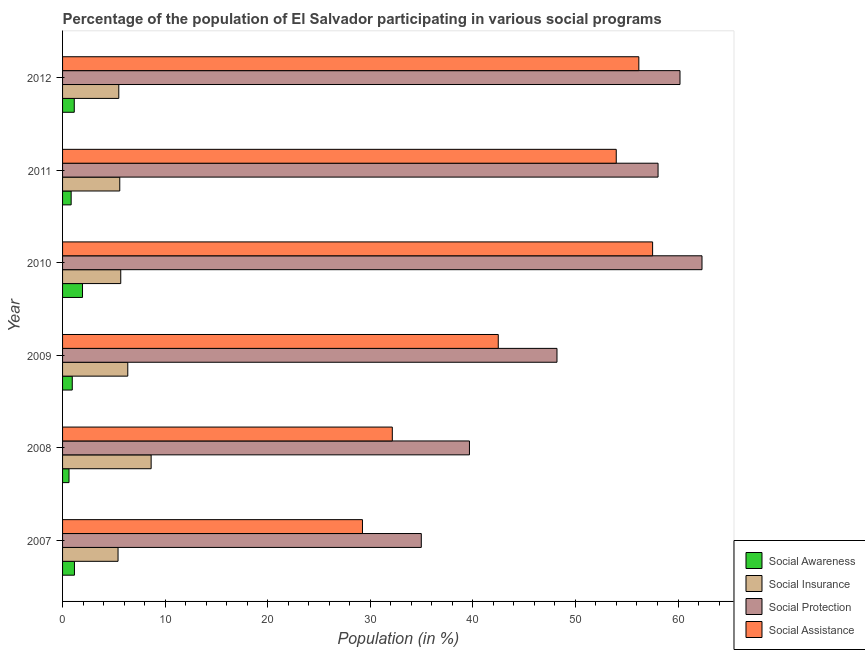How many different coloured bars are there?
Your response must be concise. 4. Are the number of bars per tick equal to the number of legend labels?
Your response must be concise. Yes. What is the label of the 1st group of bars from the top?
Provide a short and direct response. 2012. What is the participation of population in social awareness programs in 2009?
Your answer should be very brief. 0.95. Across all years, what is the maximum participation of population in social insurance programs?
Offer a very short reply. 8.63. Across all years, what is the minimum participation of population in social awareness programs?
Offer a terse response. 0.63. In which year was the participation of population in social protection programs minimum?
Ensure brevity in your answer.  2007. What is the total participation of population in social insurance programs in the graph?
Your answer should be compact. 37.13. What is the difference between the participation of population in social awareness programs in 2010 and that in 2012?
Your answer should be compact. 0.81. What is the difference between the participation of population in social assistance programs in 2009 and the participation of population in social protection programs in 2010?
Give a very brief answer. -19.86. What is the average participation of population in social assistance programs per year?
Ensure brevity in your answer.  45.26. In the year 2012, what is the difference between the participation of population in social insurance programs and participation of population in social protection programs?
Your answer should be very brief. -54.71. What is the ratio of the participation of population in social assistance programs in 2009 to that in 2010?
Provide a short and direct response. 0.74. Is the participation of population in social insurance programs in 2009 less than that in 2010?
Keep it short and to the point. No. What is the difference between the highest and the second highest participation of population in social awareness programs?
Offer a very short reply. 0.79. What is the difference between the highest and the lowest participation of population in social assistance programs?
Keep it short and to the point. 28.29. In how many years, is the participation of population in social awareness programs greater than the average participation of population in social awareness programs taken over all years?
Offer a very short reply. 3. Is it the case that in every year, the sum of the participation of population in social protection programs and participation of population in social awareness programs is greater than the sum of participation of population in social assistance programs and participation of population in social insurance programs?
Provide a succinct answer. Yes. What does the 4th bar from the top in 2011 represents?
Keep it short and to the point. Social Awareness. What does the 3rd bar from the bottom in 2010 represents?
Ensure brevity in your answer.  Social Protection. Are all the bars in the graph horizontal?
Provide a short and direct response. Yes. How many years are there in the graph?
Ensure brevity in your answer.  6. Are the values on the major ticks of X-axis written in scientific E-notation?
Ensure brevity in your answer.  No. How many legend labels are there?
Your response must be concise. 4. What is the title of the graph?
Ensure brevity in your answer.  Percentage of the population of El Salvador participating in various social programs . Does "Taxes on income" appear as one of the legend labels in the graph?
Give a very brief answer. No. What is the Population (in %) of Social Awareness in 2007?
Make the answer very short. 1.16. What is the Population (in %) of Social Insurance in 2007?
Provide a succinct answer. 5.41. What is the Population (in %) in Social Protection in 2007?
Make the answer very short. 34.97. What is the Population (in %) of Social Assistance in 2007?
Offer a terse response. 29.24. What is the Population (in %) of Social Awareness in 2008?
Give a very brief answer. 0.63. What is the Population (in %) of Social Insurance in 2008?
Your answer should be compact. 8.63. What is the Population (in %) of Social Protection in 2008?
Provide a short and direct response. 39.67. What is the Population (in %) of Social Assistance in 2008?
Your answer should be compact. 32.15. What is the Population (in %) of Social Awareness in 2009?
Ensure brevity in your answer.  0.95. What is the Population (in %) in Social Insurance in 2009?
Ensure brevity in your answer.  6.36. What is the Population (in %) in Social Protection in 2009?
Your response must be concise. 48.2. What is the Population (in %) in Social Assistance in 2009?
Provide a short and direct response. 42.48. What is the Population (in %) in Social Awareness in 2010?
Offer a terse response. 1.95. What is the Population (in %) in Social Insurance in 2010?
Offer a very short reply. 5.67. What is the Population (in %) in Social Protection in 2010?
Provide a short and direct response. 62.34. What is the Population (in %) of Social Assistance in 2010?
Your answer should be compact. 57.53. What is the Population (in %) of Social Awareness in 2011?
Keep it short and to the point. 0.84. What is the Population (in %) of Social Insurance in 2011?
Your answer should be very brief. 5.58. What is the Population (in %) in Social Protection in 2011?
Provide a short and direct response. 58.06. What is the Population (in %) of Social Assistance in 2011?
Ensure brevity in your answer.  53.98. What is the Population (in %) of Social Awareness in 2012?
Offer a very short reply. 1.14. What is the Population (in %) of Social Insurance in 2012?
Provide a succinct answer. 5.48. What is the Population (in %) in Social Protection in 2012?
Offer a very short reply. 60.19. What is the Population (in %) in Social Assistance in 2012?
Offer a terse response. 56.18. Across all years, what is the maximum Population (in %) in Social Awareness?
Give a very brief answer. 1.95. Across all years, what is the maximum Population (in %) of Social Insurance?
Offer a very short reply. 8.63. Across all years, what is the maximum Population (in %) in Social Protection?
Your response must be concise. 62.34. Across all years, what is the maximum Population (in %) of Social Assistance?
Your answer should be compact. 57.53. Across all years, what is the minimum Population (in %) in Social Awareness?
Make the answer very short. 0.63. Across all years, what is the minimum Population (in %) in Social Insurance?
Offer a terse response. 5.41. Across all years, what is the minimum Population (in %) in Social Protection?
Your answer should be very brief. 34.97. Across all years, what is the minimum Population (in %) of Social Assistance?
Make the answer very short. 29.24. What is the total Population (in %) of Social Awareness in the graph?
Make the answer very short. 6.66. What is the total Population (in %) of Social Insurance in the graph?
Your response must be concise. 37.13. What is the total Population (in %) of Social Protection in the graph?
Ensure brevity in your answer.  303.43. What is the total Population (in %) of Social Assistance in the graph?
Provide a succinct answer. 271.55. What is the difference between the Population (in %) in Social Awareness in 2007 and that in 2008?
Your answer should be compact. 0.53. What is the difference between the Population (in %) of Social Insurance in 2007 and that in 2008?
Provide a succinct answer. -3.23. What is the difference between the Population (in %) in Social Protection in 2007 and that in 2008?
Keep it short and to the point. -4.7. What is the difference between the Population (in %) of Social Assistance in 2007 and that in 2008?
Keep it short and to the point. -2.91. What is the difference between the Population (in %) of Social Awareness in 2007 and that in 2009?
Provide a succinct answer. 0.21. What is the difference between the Population (in %) of Social Insurance in 2007 and that in 2009?
Your answer should be very brief. -0.95. What is the difference between the Population (in %) of Social Protection in 2007 and that in 2009?
Ensure brevity in your answer.  -13.23. What is the difference between the Population (in %) in Social Assistance in 2007 and that in 2009?
Give a very brief answer. -13.24. What is the difference between the Population (in %) in Social Awareness in 2007 and that in 2010?
Provide a succinct answer. -0.79. What is the difference between the Population (in %) in Social Insurance in 2007 and that in 2010?
Your answer should be compact. -0.26. What is the difference between the Population (in %) of Social Protection in 2007 and that in 2010?
Offer a terse response. -27.37. What is the difference between the Population (in %) of Social Assistance in 2007 and that in 2010?
Your answer should be very brief. -28.29. What is the difference between the Population (in %) of Social Awareness in 2007 and that in 2011?
Offer a terse response. 0.32. What is the difference between the Population (in %) of Social Insurance in 2007 and that in 2011?
Make the answer very short. -0.17. What is the difference between the Population (in %) of Social Protection in 2007 and that in 2011?
Keep it short and to the point. -23.08. What is the difference between the Population (in %) of Social Assistance in 2007 and that in 2011?
Offer a very short reply. -24.74. What is the difference between the Population (in %) of Social Awareness in 2007 and that in 2012?
Your answer should be compact. 0.02. What is the difference between the Population (in %) of Social Insurance in 2007 and that in 2012?
Your answer should be very brief. -0.07. What is the difference between the Population (in %) of Social Protection in 2007 and that in 2012?
Your answer should be compact. -25.22. What is the difference between the Population (in %) of Social Assistance in 2007 and that in 2012?
Provide a succinct answer. -26.94. What is the difference between the Population (in %) in Social Awareness in 2008 and that in 2009?
Offer a terse response. -0.32. What is the difference between the Population (in %) of Social Insurance in 2008 and that in 2009?
Offer a very short reply. 2.28. What is the difference between the Population (in %) of Social Protection in 2008 and that in 2009?
Provide a succinct answer. -8.53. What is the difference between the Population (in %) in Social Assistance in 2008 and that in 2009?
Offer a terse response. -10.33. What is the difference between the Population (in %) in Social Awareness in 2008 and that in 2010?
Your answer should be very brief. -1.32. What is the difference between the Population (in %) of Social Insurance in 2008 and that in 2010?
Your response must be concise. 2.96. What is the difference between the Population (in %) in Social Protection in 2008 and that in 2010?
Your answer should be compact. -22.67. What is the difference between the Population (in %) in Social Assistance in 2008 and that in 2010?
Your answer should be very brief. -25.38. What is the difference between the Population (in %) in Social Awareness in 2008 and that in 2011?
Your answer should be compact. -0.21. What is the difference between the Population (in %) in Social Insurance in 2008 and that in 2011?
Keep it short and to the point. 3.06. What is the difference between the Population (in %) in Social Protection in 2008 and that in 2011?
Offer a very short reply. -18.39. What is the difference between the Population (in %) of Social Assistance in 2008 and that in 2011?
Offer a terse response. -21.83. What is the difference between the Population (in %) in Social Awareness in 2008 and that in 2012?
Ensure brevity in your answer.  -0.51. What is the difference between the Population (in %) of Social Insurance in 2008 and that in 2012?
Ensure brevity in your answer.  3.15. What is the difference between the Population (in %) of Social Protection in 2008 and that in 2012?
Give a very brief answer. -20.53. What is the difference between the Population (in %) of Social Assistance in 2008 and that in 2012?
Offer a terse response. -24.03. What is the difference between the Population (in %) in Social Awareness in 2009 and that in 2010?
Keep it short and to the point. -1. What is the difference between the Population (in %) of Social Insurance in 2009 and that in 2010?
Your answer should be compact. 0.68. What is the difference between the Population (in %) of Social Protection in 2009 and that in 2010?
Your answer should be compact. -14.14. What is the difference between the Population (in %) in Social Assistance in 2009 and that in 2010?
Give a very brief answer. -15.05. What is the difference between the Population (in %) in Social Awareness in 2009 and that in 2011?
Keep it short and to the point. 0.11. What is the difference between the Population (in %) in Social Insurance in 2009 and that in 2011?
Offer a very short reply. 0.78. What is the difference between the Population (in %) of Social Protection in 2009 and that in 2011?
Ensure brevity in your answer.  -9.86. What is the difference between the Population (in %) of Social Assistance in 2009 and that in 2011?
Give a very brief answer. -11.5. What is the difference between the Population (in %) in Social Awareness in 2009 and that in 2012?
Make the answer very short. -0.2. What is the difference between the Population (in %) of Social Protection in 2009 and that in 2012?
Keep it short and to the point. -11.99. What is the difference between the Population (in %) in Social Assistance in 2009 and that in 2012?
Keep it short and to the point. -13.7. What is the difference between the Population (in %) of Social Awareness in 2010 and that in 2011?
Keep it short and to the point. 1.11. What is the difference between the Population (in %) of Social Insurance in 2010 and that in 2011?
Provide a succinct answer. 0.1. What is the difference between the Population (in %) of Social Protection in 2010 and that in 2011?
Your response must be concise. 4.28. What is the difference between the Population (in %) in Social Assistance in 2010 and that in 2011?
Ensure brevity in your answer.  3.55. What is the difference between the Population (in %) of Social Awareness in 2010 and that in 2012?
Offer a very short reply. 0.8. What is the difference between the Population (in %) of Social Insurance in 2010 and that in 2012?
Offer a very short reply. 0.19. What is the difference between the Population (in %) of Social Protection in 2010 and that in 2012?
Provide a short and direct response. 2.15. What is the difference between the Population (in %) in Social Assistance in 2010 and that in 2012?
Give a very brief answer. 1.34. What is the difference between the Population (in %) in Social Awareness in 2011 and that in 2012?
Ensure brevity in your answer.  -0.3. What is the difference between the Population (in %) in Social Insurance in 2011 and that in 2012?
Provide a short and direct response. 0.09. What is the difference between the Population (in %) in Social Protection in 2011 and that in 2012?
Ensure brevity in your answer.  -2.14. What is the difference between the Population (in %) of Social Assistance in 2011 and that in 2012?
Your answer should be very brief. -2.2. What is the difference between the Population (in %) in Social Awareness in 2007 and the Population (in %) in Social Insurance in 2008?
Offer a terse response. -7.48. What is the difference between the Population (in %) in Social Awareness in 2007 and the Population (in %) in Social Protection in 2008?
Your answer should be compact. -38.51. What is the difference between the Population (in %) of Social Awareness in 2007 and the Population (in %) of Social Assistance in 2008?
Your response must be concise. -30.99. What is the difference between the Population (in %) in Social Insurance in 2007 and the Population (in %) in Social Protection in 2008?
Offer a very short reply. -34.26. What is the difference between the Population (in %) of Social Insurance in 2007 and the Population (in %) of Social Assistance in 2008?
Provide a succinct answer. -26.74. What is the difference between the Population (in %) of Social Protection in 2007 and the Population (in %) of Social Assistance in 2008?
Your answer should be very brief. 2.83. What is the difference between the Population (in %) of Social Awareness in 2007 and the Population (in %) of Social Insurance in 2009?
Provide a succinct answer. -5.2. What is the difference between the Population (in %) of Social Awareness in 2007 and the Population (in %) of Social Protection in 2009?
Your answer should be very brief. -47.04. What is the difference between the Population (in %) in Social Awareness in 2007 and the Population (in %) in Social Assistance in 2009?
Keep it short and to the point. -41.32. What is the difference between the Population (in %) of Social Insurance in 2007 and the Population (in %) of Social Protection in 2009?
Offer a very short reply. -42.79. What is the difference between the Population (in %) of Social Insurance in 2007 and the Population (in %) of Social Assistance in 2009?
Your answer should be compact. -37.07. What is the difference between the Population (in %) of Social Protection in 2007 and the Population (in %) of Social Assistance in 2009?
Provide a short and direct response. -7.5. What is the difference between the Population (in %) in Social Awareness in 2007 and the Population (in %) in Social Insurance in 2010?
Ensure brevity in your answer.  -4.51. What is the difference between the Population (in %) of Social Awareness in 2007 and the Population (in %) of Social Protection in 2010?
Offer a terse response. -61.18. What is the difference between the Population (in %) of Social Awareness in 2007 and the Population (in %) of Social Assistance in 2010?
Your answer should be very brief. -56.37. What is the difference between the Population (in %) in Social Insurance in 2007 and the Population (in %) in Social Protection in 2010?
Offer a terse response. -56.93. What is the difference between the Population (in %) of Social Insurance in 2007 and the Population (in %) of Social Assistance in 2010?
Provide a short and direct response. -52.12. What is the difference between the Population (in %) in Social Protection in 2007 and the Population (in %) in Social Assistance in 2010?
Give a very brief answer. -22.55. What is the difference between the Population (in %) in Social Awareness in 2007 and the Population (in %) in Social Insurance in 2011?
Make the answer very short. -4.42. What is the difference between the Population (in %) in Social Awareness in 2007 and the Population (in %) in Social Protection in 2011?
Make the answer very short. -56.9. What is the difference between the Population (in %) of Social Awareness in 2007 and the Population (in %) of Social Assistance in 2011?
Your response must be concise. -52.82. What is the difference between the Population (in %) in Social Insurance in 2007 and the Population (in %) in Social Protection in 2011?
Ensure brevity in your answer.  -52.65. What is the difference between the Population (in %) of Social Insurance in 2007 and the Population (in %) of Social Assistance in 2011?
Provide a short and direct response. -48.57. What is the difference between the Population (in %) of Social Protection in 2007 and the Population (in %) of Social Assistance in 2011?
Provide a succinct answer. -19.01. What is the difference between the Population (in %) in Social Awareness in 2007 and the Population (in %) in Social Insurance in 2012?
Provide a short and direct response. -4.32. What is the difference between the Population (in %) of Social Awareness in 2007 and the Population (in %) of Social Protection in 2012?
Ensure brevity in your answer.  -59.03. What is the difference between the Population (in %) of Social Awareness in 2007 and the Population (in %) of Social Assistance in 2012?
Ensure brevity in your answer.  -55.02. What is the difference between the Population (in %) of Social Insurance in 2007 and the Population (in %) of Social Protection in 2012?
Ensure brevity in your answer.  -54.79. What is the difference between the Population (in %) of Social Insurance in 2007 and the Population (in %) of Social Assistance in 2012?
Give a very brief answer. -50.77. What is the difference between the Population (in %) of Social Protection in 2007 and the Population (in %) of Social Assistance in 2012?
Offer a very short reply. -21.21. What is the difference between the Population (in %) in Social Awareness in 2008 and the Population (in %) in Social Insurance in 2009?
Your answer should be very brief. -5.73. What is the difference between the Population (in %) of Social Awareness in 2008 and the Population (in %) of Social Protection in 2009?
Offer a terse response. -47.57. What is the difference between the Population (in %) of Social Awareness in 2008 and the Population (in %) of Social Assistance in 2009?
Offer a very short reply. -41.85. What is the difference between the Population (in %) in Social Insurance in 2008 and the Population (in %) in Social Protection in 2009?
Ensure brevity in your answer.  -39.57. What is the difference between the Population (in %) in Social Insurance in 2008 and the Population (in %) in Social Assistance in 2009?
Your answer should be compact. -33.84. What is the difference between the Population (in %) in Social Protection in 2008 and the Population (in %) in Social Assistance in 2009?
Make the answer very short. -2.81. What is the difference between the Population (in %) of Social Awareness in 2008 and the Population (in %) of Social Insurance in 2010?
Your answer should be very brief. -5.04. What is the difference between the Population (in %) of Social Awareness in 2008 and the Population (in %) of Social Protection in 2010?
Give a very brief answer. -61.71. What is the difference between the Population (in %) of Social Awareness in 2008 and the Population (in %) of Social Assistance in 2010?
Provide a short and direct response. -56.9. What is the difference between the Population (in %) of Social Insurance in 2008 and the Population (in %) of Social Protection in 2010?
Ensure brevity in your answer.  -53.71. What is the difference between the Population (in %) in Social Insurance in 2008 and the Population (in %) in Social Assistance in 2010?
Make the answer very short. -48.89. What is the difference between the Population (in %) of Social Protection in 2008 and the Population (in %) of Social Assistance in 2010?
Your answer should be compact. -17.86. What is the difference between the Population (in %) of Social Awareness in 2008 and the Population (in %) of Social Insurance in 2011?
Give a very brief answer. -4.95. What is the difference between the Population (in %) in Social Awareness in 2008 and the Population (in %) in Social Protection in 2011?
Provide a succinct answer. -57.43. What is the difference between the Population (in %) in Social Awareness in 2008 and the Population (in %) in Social Assistance in 2011?
Ensure brevity in your answer.  -53.35. What is the difference between the Population (in %) in Social Insurance in 2008 and the Population (in %) in Social Protection in 2011?
Offer a very short reply. -49.42. What is the difference between the Population (in %) of Social Insurance in 2008 and the Population (in %) of Social Assistance in 2011?
Make the answer very short. -45.34. What is the difference between the Population (in %) of Social Protection in 2008 and the Population (in %) of Social Assistance in 2011?
Make the answer very short. -14.31. What is the difference between the Population (in %) of Social Awareness in 2008 and the Population (in %) of Social Insurance in 2012?
Your answer should be very brief. -4.85. What is the difference between the Population (in %) of Social Awareness in 2008 and the Population (in %) of Social Protection in 2012?
Ensure brevity in your answer.  -59.57. What is the difference between the Population (in %) in Social Awareness in 2008 and the Population (in %) in Social Assistance in 2012?
Your response must be concise. -55.55. What is the difference between the Population (in %) of Social Insurance in 2008 and the Population (in %) of Social Protection in 2012?
Your answer should be compact. -51.56. What is the difference between the Population (in %) in Social Insurance in 2008 and the Population (in %) in Social Assistance in 2012?
Provide a short and direct response. -47.55. What is the difference between the Population (in %) in Social Protection in 2008 and the Population (in %) in Social Assistance in 2012?
Offer a terse response. -16.51. What is the difference between the Population (in %) in Social Awareness in 2009 and the Population (in %) in Social Insurance in 2010?
Ensure brevity in your answer.  -4.73. What is the difference between the Population (in %) in Social Awareness in 2009 and the Population (in %) in Social Protection in 2010?
Ensure brevity in your answer.  -61.4. What is the difference between the Population (in %) in Social Awareness in 2009 and the Population (in %) in Social Assistance in 2010?
Your response must be concise. -56.58. What is the difference between the Population (in %) in Social Insurance in 2009 and the Population (in %) in Social Protection in 2010?
Provide a short and direct response. -55.98. What is the difference between the Population (in %) of Social Insurance in 2009 and the Population (in %) of Social Assistance in 2010?
Provide a succinct answer. -51.17. What is the difference between the Population (in %) in Social Protection in 2009 and the Population (in %) in Social Assistance in 2010?
Keep it short and to the point. -9.32. What is the difference between the Population (in %) of Social Awareness in 2009 and the Population (in %) of Social Insurance in 2011?
Keep it short and to the point. -4.63. What is the difference between the Population (in %) in Social Awareness in 2009 and the Population (in %) in Social Protection in 2011?
Provide a short and direct response. -57.11. What is the difference between the Population (in %) in Social Awareness in 2009 and the Population (in %) in Social Assistance in 2011?
Give a very brief answer. -53.03. What is the difference between the Population (in %) in Social Insurance in 2009 and the Population (in %) in Social Protection in 2011?
Your answer should be very brief. -51.7. What is the difference between the Population (in %) of Social Insurance in 2009 and the Population (in %) of Social Assistance in 2011?
Offer a very short reply. -47.62. What is the difference between the Population (in %) of Social Protection in 2009 and the Population (in %) of Social Assistance in 2011?
Offer a very short reply. -5.78. What is the difference between the Population (in %) in Social Awareness in 2009 and the Population (in %) in Social Insurance in 2012?
Give a very brief answer. -4.54. What is the difference between the Population (in %) in Social Awareness in 2009 and the Population (in %) in Social Protection in 2012?
Make the answer very short. -59.25. What is the difference between the Population (in %) of Social Awareness in 2009 and the Population (in %) of Social Assistance in 2012?
Offer a very short reply. -55.24. What is the difference between the Population (in %) of Social Insurance in 2009 and the Population (in %) of Social Protection in 2012?
Offer a very short reply. -53.84. What is the difference between the Population (in %) in Social Insurance in 2009 and the Population (in %) in Social Assistance in 2012?
Your answer should be very brief. -49.82. What is the difference between the Population (in %) in Social Protection in 2009 and the Population (in %) in Social Assistance in 2012?
Offer a very short reply. -7.98. What is the difference between the Population (in %) in Social Awareness in 2010 and the Population (in %) in Social Insurance in 2011?
Your answer should be very brief. -3.63. What is the difference between the Population (in %) in Social Awareness in 2010 and the Population (in %) in Social Protection in 2011?
Your response must be concise. -56.11. What is the difference between the Population (in %) in Social Awareness in 2010 and the Population (in %) in Social Assistance in 2011?
Your answer should be compact. -52.03. What is the difference between the Population (in %) in Social Insurance in 2010 and the Population (in %) in Social Protection in 2011?
Your response must be concise. -52.38. What is the difference between the Population (in %) of Social Insurance in 2010 and the Population (in %) of Social Assistance in 2011?
Offer a terse response. -48.31. What is the difference between the Population (in %) in Social Protection in 2010 and the Population (in %) in Social Assistance in 2011?
Your answer should be very brief. 8.36. What is the difference between the Population (in %) of Social Awareness in 2010 and the Population (in %) of Social Insurance in 2012?
Ensure brevity in your answer.  -3.54. What is the difference between the Population (in %) in Social Awareness in 2010 and the Population (in %) in Social Protection in 2012?
Provide a short and direct response. -58.25. What is the difference between the Population (in %) of Social Awareness in 2010 and the Population (in %) of Social Assistance in 2012?
Offer a terse response. -54.24. What is the difference between the Population (in %) of Social Insurance in 2010 and the Population (in %) of Social Protection in 2012?
Your answer should be very brief. -54.52. What is the difference between the Population (in %) in Social Insurance in 2010 and the Population (in %) in Social Assistance in 2012?
Keep it short and to the point. -50.51. What is the difference between the Population (in %) in Social Protection in 2010 and the Population (in %) in Social Assistance in 2012?
Provide a short and direct response. 6.16. What is the difference between the Population (in %) in Social Awareness in 2011 and the Population (in %) in Social Insurance in 2012?
Keep it short and to the point. -4.65. What is the difference between the Population (in %) of Social Awareness in 2011 and the Population (in %) of Social Protection in 2012?
Your answer should be very brief. -59.36. What is the difference between the Population (in %) of Social Awareness in 2011 and the Population (in %) of Social Assistance in 2012?
Offer a very short reply. -55.34. What is the difference between the Population (in %) in Social Insurance in 2011 and the Population (in %) in Social Protection in 2012?
Make the answer very short. -54.62. What is the difference between the Population (in %) in Social Insurance in 2011 and the Population (in %) in Social Assistance in 2012?
Offer a terse response. -50.6. What is the difference between the Population (in %) in Social Protection in 2011 and the Population (in %) in Social Assistance in 2012?
Give a very brief answer. 1.88. What is the average Population (in %) in Social Awareness per year?
Give a very brief answer. 1.11. What is the average Population (in %) of Social Insurance per year?
Your answer should be compact. 6.19. What is the average Population (in %) in Social Protection per year?
Offer a very short reply. 50.57. What is the average Population (in %) in Social Assistance per year?
Offer a very short reply. 45.26. In the year 2007, what is the difference between the Population (in %) of Social Awareness and Population (in %) of Social Insurance?
Your answer should be very brief. -4.25. In the year 2007, what is the difference between the Population (in %) in Social Awareness and Population (in %) in Social Protection?
Your answer should be very brief. -33.81. In the year 2007, what is the difference between the Population (in %) in Social Awareness and Population (in %) in Social Assistance?
Offer a very short reply. -28.08. In the year 2007, what is the difference between the Population (in %) in Social Insurance and Population (in %) in Social Protection?
Give a very brief answer. -29.56. In the year 2007, what is the difference between the Population (in %) of Social Insurance and Population (in %) of Social Assistance?
Ensure brevity in your answer.  -23.83. In the year 2007, what is the difference between the Population (in %) of Social Protection and Population (in %) of Social Assistance?
Make the answer very short. 5.74. In the year 2008, what is the difference between the Population (in %) in Social Awareness and Population (in %) in Social Insurance?
Give a very brief answer. -8.01. In the year 2008, what is the difference between the Population (in %) in Social Awareness and Population (in %) in Social Protection?
Provide a short and direct response. -39.04. In the year 2008, what is the difference between the Population (in %) in Social Awareness and Population (in %) in Social Assistance?
Offer a very short reply. -31.52. In the year 2008, what is the difference between the Population (in %) of Social Insurance and Population (in %) of Social Protection?
Provide a succinct answer. -31.03. In the year 2008, what is the difference between the Population (in %) of Social Insurance and Population (in %) of Social Assistance?
Make the answer very short. -23.51. In the year 2008, what is the difference between the Population (in %) of Social Protection and Population (in %) of Social Assistance?
Ensure brevity in your answer.  7.52. In the year 2009, what is the difference between the Population (in %) in Social Awareness and Population (in %) in Social Insurance?
Give a very brief answer. -5.41. In the year 2009, what is the difference between the Population (in %) of Social Awareness and Population (in %) of Social Protection?
Your answer should be compact. -47.26. In the year 2009, what is the difference between the Population (in %) of Social Awareness and Population (in %) of Social Assistance?
Your answer should be very brief. -41.53. In the year 2009, what is the difference between the Population (in %) in Social Insurance and Population (in %) in Social Protection?
Keep it short and to the point. -41.84. In the year 2009, what is the difference between the Population (in %) of Social Insurance and Population (in %) of Social Assistance?
Give a very brief answer. -36.12. In the year 2009, what is the difference between the Population (in %) of Social Protection and Population (in %) of Social Assistance?
Your response must be concise. 5.72. In the year 2010, what is the difference between the Population (in %) in Social Awareness and Population (in %) in Social Insurance?
Ensure brevity in your answer.  -3.73. In the year 2010, what is the difference between the Population (in %) of Social Awareness and Population (in %) of Social Protection?
Your answer should be very brief. -60.39. In the year 2010, what is the difference between the Population (in %) of Social Awareness and Population (in %) of Social Assistance?
Make the answer very short. -55.58. In the year 2010, what is the difference between the Population (in %) of Social Insurance and Population (in %) of Social Protection?
Make the answer very short. -56.67. In the year 2010, what is the difference between the Population (in %) of Social Insurance and Population (in %) of Social Assistance?
Offer a very short reply. -51.85. In the year 2010, what is the difference between the Population (in %) of Social Protection and Population (in %) of Social Assistance?
Provide a short and direct response. 4.82. In the year 2011, what is the difference between the Population (in %) in Social Awareness and Population (in %) in Social Insurance?
Keep it short and to the point. -4.74. In the year 2011, what is the difference between the Population (in %) in Social Awareness and Population (in %) in Social Protection?
Offer a very short reply. -57.22. In the year 2011, what is the difference between the Population (in %) in Social Awareness and Population (in %) in Social Assistance?
Your response must be concise. -53.14. In the year 2011, what is the difference between the Population (in %) in Social Insurance and Population (in %) in Social Protection?
Your answer should be compact. -52.48. In the year 2011, what is the difference between the Population (in %) of Social Insurance and Population (in %) of Social Assistance?
Provide a short and direct response. -48.4. In the year 2011, what is the difference between the Population (in %) in Social Protection and Population (in %) in Social Assistance?
Make the answer very short. 4.08. In the year 2012, what is the difference between the Population (in %) in Social Awareness and Population (in %) in Social Insurance?
Your answer should be very brief. -4.34. In the year 2012, what is the difference between the Population (in %) in Social Awareness and Population (in %) in Social Protection?
Make the answer very short. -59.05. In the year 2012, what is the difference between the Population (in %) of Social Awareness and Population (in %) of Social Assistance?
Give a very brief answer. -55.04. In the year 2012, what is the difference between the Population (in %) of Social Insurance and Population (in %) of Social Protection?
Make the answer very short. -54.71. In the year 2012, what is the difference between the Population (in %) of Social Insurance and Population (in %) of Social Assistance?
Make the answer very short. -50.7. In the year 2012, what is the difference between the Population (in %) of Social Protection and Population (in %) of Social Assistance?
Provide a short and direct response. 4.01. What is the ratio of the Population (in %) in Social Awareness in 2007 to that in 2008?
Ensure brevity in your answer.  1.84. What is the ratio of the Population (in %) in Social Insurance in 2007 to that in 2008?
Your answer should be compact. 0.63. What is the ratio of the Population (in %) of Social Protection in 2007 to that in 2008?
Your answer should be compact. 0.88. What is the ratio of the Population (in %) in Social Assistance in 2007 to that in 2008?
Provide a short and direct response. 0.91. What is the ratio of the Population (in %) in Social Awareness in 2007 to that in 2009?
Your answer should be compact. 1.23. What is the ratio of the Population (in %) in Social Insurance in 2007 to that in 2009?
Offer a terse response. 0.85. What is the ratio of the Population (in %) of Social Protection in 2007 to that in 2009?
Make the answer very short. 0.73. What is the ratio of the Population (in %) in Social Assistance in 2007 to that in 2009?
Provide a succinct answer. 0.69. What is the ratio of the Population (in %) in Social Awareness in 2007 to that in 2010?
Give a very brief answer. 0.6. What is the ratio of the Population (in %) of Social Insurance in 2007 to that in 2010?
Keep it short and to the point. 0.95. What is the ratio of the Population (in %) in Social Protection in 2007 to that in 2010?
Give a very brief answer. 0.56. What is the ratio of the Population (in %) in Social Assistance in 2007 to that in 2010?
Provide a succinct answer. 0.51. What is the ratio of the Population (in %) of Social Awareness in 2007 to that in 2011?
Provide a succinct answer. 1.38. What is the ratio of the Population (in %) in Social Insurance in 2007 to that in 2011?
Ensure brevity in your answer.  0.97. What is the ratio of the Population (in %) in Social Protection in 2007 to that in 2011?
Give a very brief answer. 0.6. What is the ratio of the Population (in %) of Social Assistance in 2007 to that in 2011?
Ensure brevity in your answer.  0.54. What is the ratio of the Population (in %) in Social Awareness in 2007 to that in 2012?
Provide a succinct answer. 1.02. What is the ratio of the Population (in %) in Social Insurance in 2007 to that in 2012?
Make the answer very short. 0.99. What is the ratio of the Population (in %) of Social Protection in 2007 to that in 2012?
Provide a succinct answer. 0.58. What is the ratio of the Population (in %) of Social Assistance in 2007 to that in 2012?
Your response must be concise. 0.52. What is the ratio of the Population (in %) of Social Awareness in 2008 to that in 2009?
Your answer should be compact. 0.67. What is the ratio of the Population (in %) of Social Insurance in 2008 to that in 2009?
Your answer should be very brief. 1.36. What is the ratio of the Population (in %) in Social Protection in 2008 to that in 2009?
Your answer should be compact. 0.82. What is the ratio of the Population (in %) in Social Assistance in 2008 to that in 2009?
Provide a short and direct response. 0.76. What is the ratio of the Population (in %) of Social Awareness in 2008 to that in 2010?
Keep it short and to the point. 0.32. What is the ratio of the Population (in %) in Social Insurance in 2008 to that in 2010?
Ensure brevity in your answer.  1.52. What is the ratio of the Population (in %) in Social Protection in 2008 to that in 2010?
Ensure brevity in your answer.  0.64. What is the ratio of the Population (in %) in Social Assistance in 2008 to that in 2010?
Provide a short and direct response. 0.56. What is the ratio of the Population (in %) in Social Awareness in 2008 to that in 2011?
Make the answer very short. 0.75. What is the ratio of the Population (in %) of Social Insurance in 2008 to that in 2011?
Give a very brief answer. 1.55. What is the ratio of the Population (in %) in Social Protection in 2008 to that in 2011?
Offer a terse response. 0.68. What is the ratio of the Population (in %) in Social Assistance in 2008 to that in 2011?
Your response must be concise. 0.6. What is the ratio of the Population (in %) in Social Awareness in 2008 to that in 2012?
Provide a short and direct response. 0.55. What is the ratio of the Population (in %) of Social Insurance in 2008 to that in 2012?
Offer a terse response. 1.57. What is the ratio of the Population (in %) of Social Protection in 2008 to that in 2012?
Your answer should be compact. 0.66. What is the ratio of the Population (in %) in Social Assistance in 2008 to that in 2012?
Make the answer very short. 0.57. What is the ratio of the Population (in %) in Social Awareness in 2009 to that in 2010?
Your answer should be compact. 0.49. What is the ratio of the Population (in %) in Social Insurance in 2009 to that in 2010?
Your answer should be very brief. 1.12. What is the ratio of the Population (in %) of Social Protection in 2009 to that in 2010?
Offer a very short reply. 0.77. What is the ratio of the Population (in %) in Social Assistance in 2009 to that in 2010?
Offer a terse response. 0.74. What is the ratio of the Population (in %) in Social Awareness in 2009 to that in 2011?
Offer a terse response. 1.13. What is the ratio of the Population (in %) of Social Insurance in 2009 to that in 2011?
Offer a terse response. 1.14. What is the ratio of the Population (in %) of Social Protection in 2009 to that in 2011?
Your answer should be compact. 0.83. What is the ratio of the Population (in %) of Social Assistance in 2009 to that in 2011?
Offer a very short reply. 0.79. What is the ratio of the Population (in %) of Social Awareness in 2009 to that in 2012?
Keep it short and to the point. 0.83. What is the ratio of the Population (in %) of Social Insurance in 2009 to that in 2012?
Give a very brief answer. 1.16. What is the ratio of the Population (in %) of Social Protection in 2009 to that in 2012?
Make the answer very short. 0.8. What is the ratio of the Population (in %) in Social Assistance in 2009 to that in 2012?
Give a very brief answer. 0.76. What is the ratio of the Population (in %) in Social Awareness in 2010 to that in 2011?
Your answer should be compact. 2.32. What is the ratio of the Population (in %) of Social Insurance in 2010 to that in 2011?
Provide a succinct answer. 1.02. What is the ratio of the Population (in %) in Social Protection in 2010 to that in 2011?
Provide a short and direct response. 1.07. What is the ratio of the Population (in %) of Social Assistance in 2010 to that in 2011?
Make the answer very short. 1.07. What is the ratio of the Population (in %) in Social Awareness in 2010 to that in 2012?
Your response must be concise. 1.71. What is the ratio of the Population (in %) in Social Insurance in 2010 to that in 2012?
Your answer should be compact. 1.03. What is the ratio of the Population (in %) of Social Protection in 2010 to that in 2012?
Keep it short and to the point. 1.04. What is the ratio of the Population (in %) of Social Assistance in 2010 to that in 2012?
Your answer should be very brief. 1.02. What is the ratio of the Population (in %) of Social Awareness in 2011 to that in 2012?
Your answer should be very brief. 0.73. What is the ratio of the Population (in %) of Social Insurance in 2011 to that in 2012?
Keep it short and to the point. 1.02. What is the ratio of the Population (in %) in Social Protection in 2011 to that in 2012?
Offer a terse response. 0.96. What is the ratio of the Population (in %) in Social Assistance in 2011 to that in 2012?
Your answer should be compact. 0.96. What is the difference between the highest and the second highest Population (in %) of Social Awareness?
Provide a succinct answer. 0.79. What is the difference between the highest and the second highest Population (in %) in Social Insurance?
Provide a succinct answer. 2.28. What is the difference between the highest and the second highest Population (in %) of Social Protection?
Provide a short and direct response. 2.15. What is the difference between the highest and the second highest Population (in %) in Social Assistance?
Keep it short and to the point. 1.34. What is the difference between the highest and the lowest Population (in %) in Social Awareness?
Ensure brevity in your answer.  1.32. What is the difference between the highest and the lowest Population (in %) of Social Insurance?
Ensure brevity in your answer.  3.23. What is the difference between the highest and the lowest Population (in %) of Social Protection?
Provide a short and direct response. 27.37. What is the difference between the highest and the lowest Population (in %) in Social Assistance?
Provide a succinct answer. 28.29. 